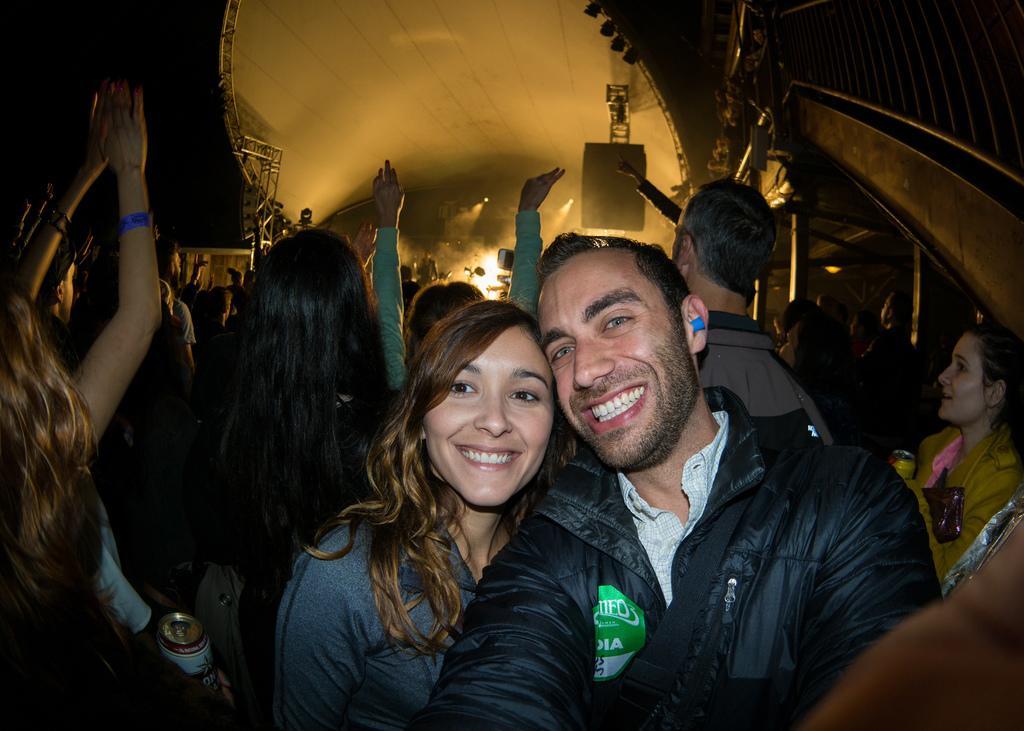In one or two sentences, can you explain what this image depicts? In this image there is a man and a woman taking picture, in the background there are people standing and there are lights. 